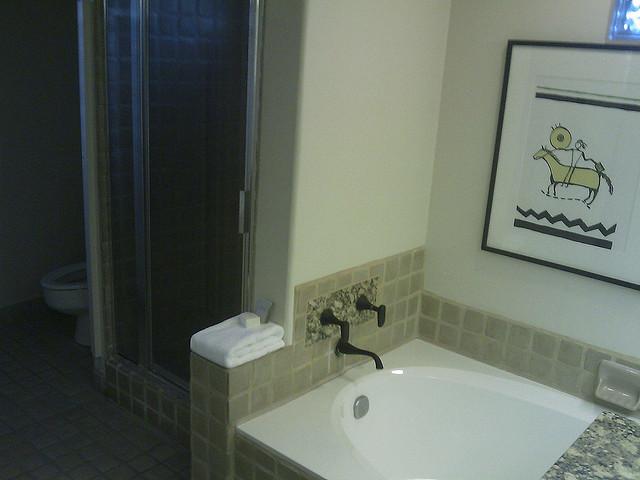What is the size of this room?
Keep it brief. Large. Is the tile the same in the shower and bath?
Be succinct. Yes. What are the brown cylinders on the side of the tub?
Quick response, please. Faucet. How many tiles on wall?
Keep it brief. Many. What color is the wall in this room?
Give a very brief answer. White. Is there a picture behind the sink?
Keep it brief. Yes. What style of art hands on the wall?
Answer briefly. Native american. Does the shower require a shower curtain?
Write a very short answer. No. Is there a mirror on the wall?
Quick response, please. No. There is a washing detergent?
Concise answer only. No. How many mirrors are in the picture?
Write a very short answer. 0. Can you see the photographer in his picture?
Give a very brief answer. No. Is this bathroom finished?
Be succinct. Yes. Does the tub have a handheld shower?
Answer briefly. No. What is the item draped over the tub?
Give a very brief answer. Towel. Does the poster remind people to practice good hygiene?
Concise answer only. No. Is there toilet paper in this picture?
Be succinct. No. How many picture frames are in this picture?
Concise answer only. 1. What color is the sink faucet?
Quick response, please. Black. Would this be considered a spacious bathroom?
Concise answer only. Yes. What animal is framed?
Quick response, please. Horse. What color are the taps?
Be succinct. Black. 